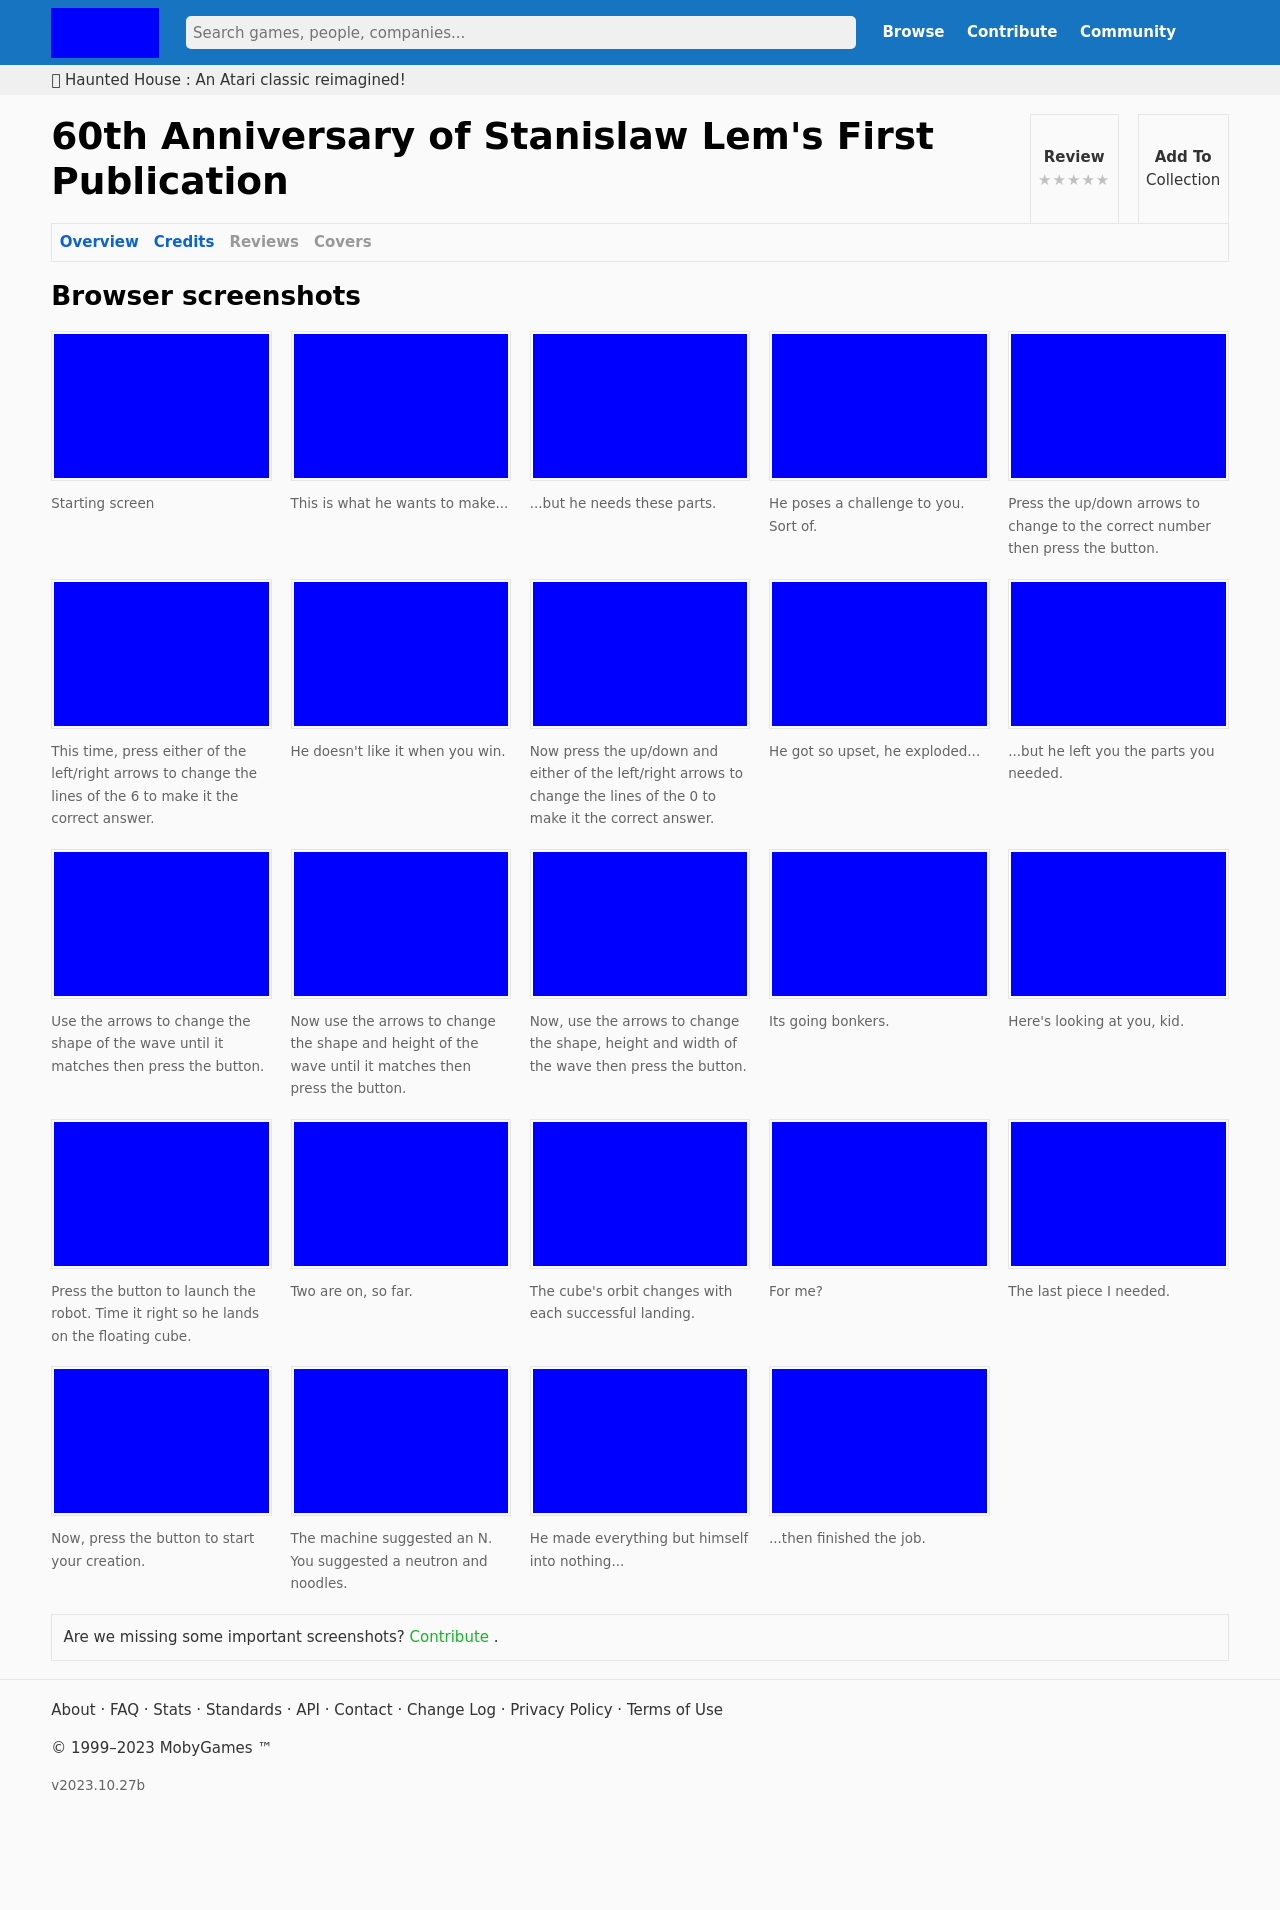How does the design of the interface contribute to the usability of the game? The interface design in the screenshots is minimalist and clean, which helps reduce player distraction and focuses attention on gameplay elements. The clear, legible text and streamlined layout ensure that players can easily navigate through tasks and instructions. Moreover, the use of bold colors likely serves to emphasize key interactions or active elements, enhancing both the aesthetic appeal and the functional clarity of the game. 